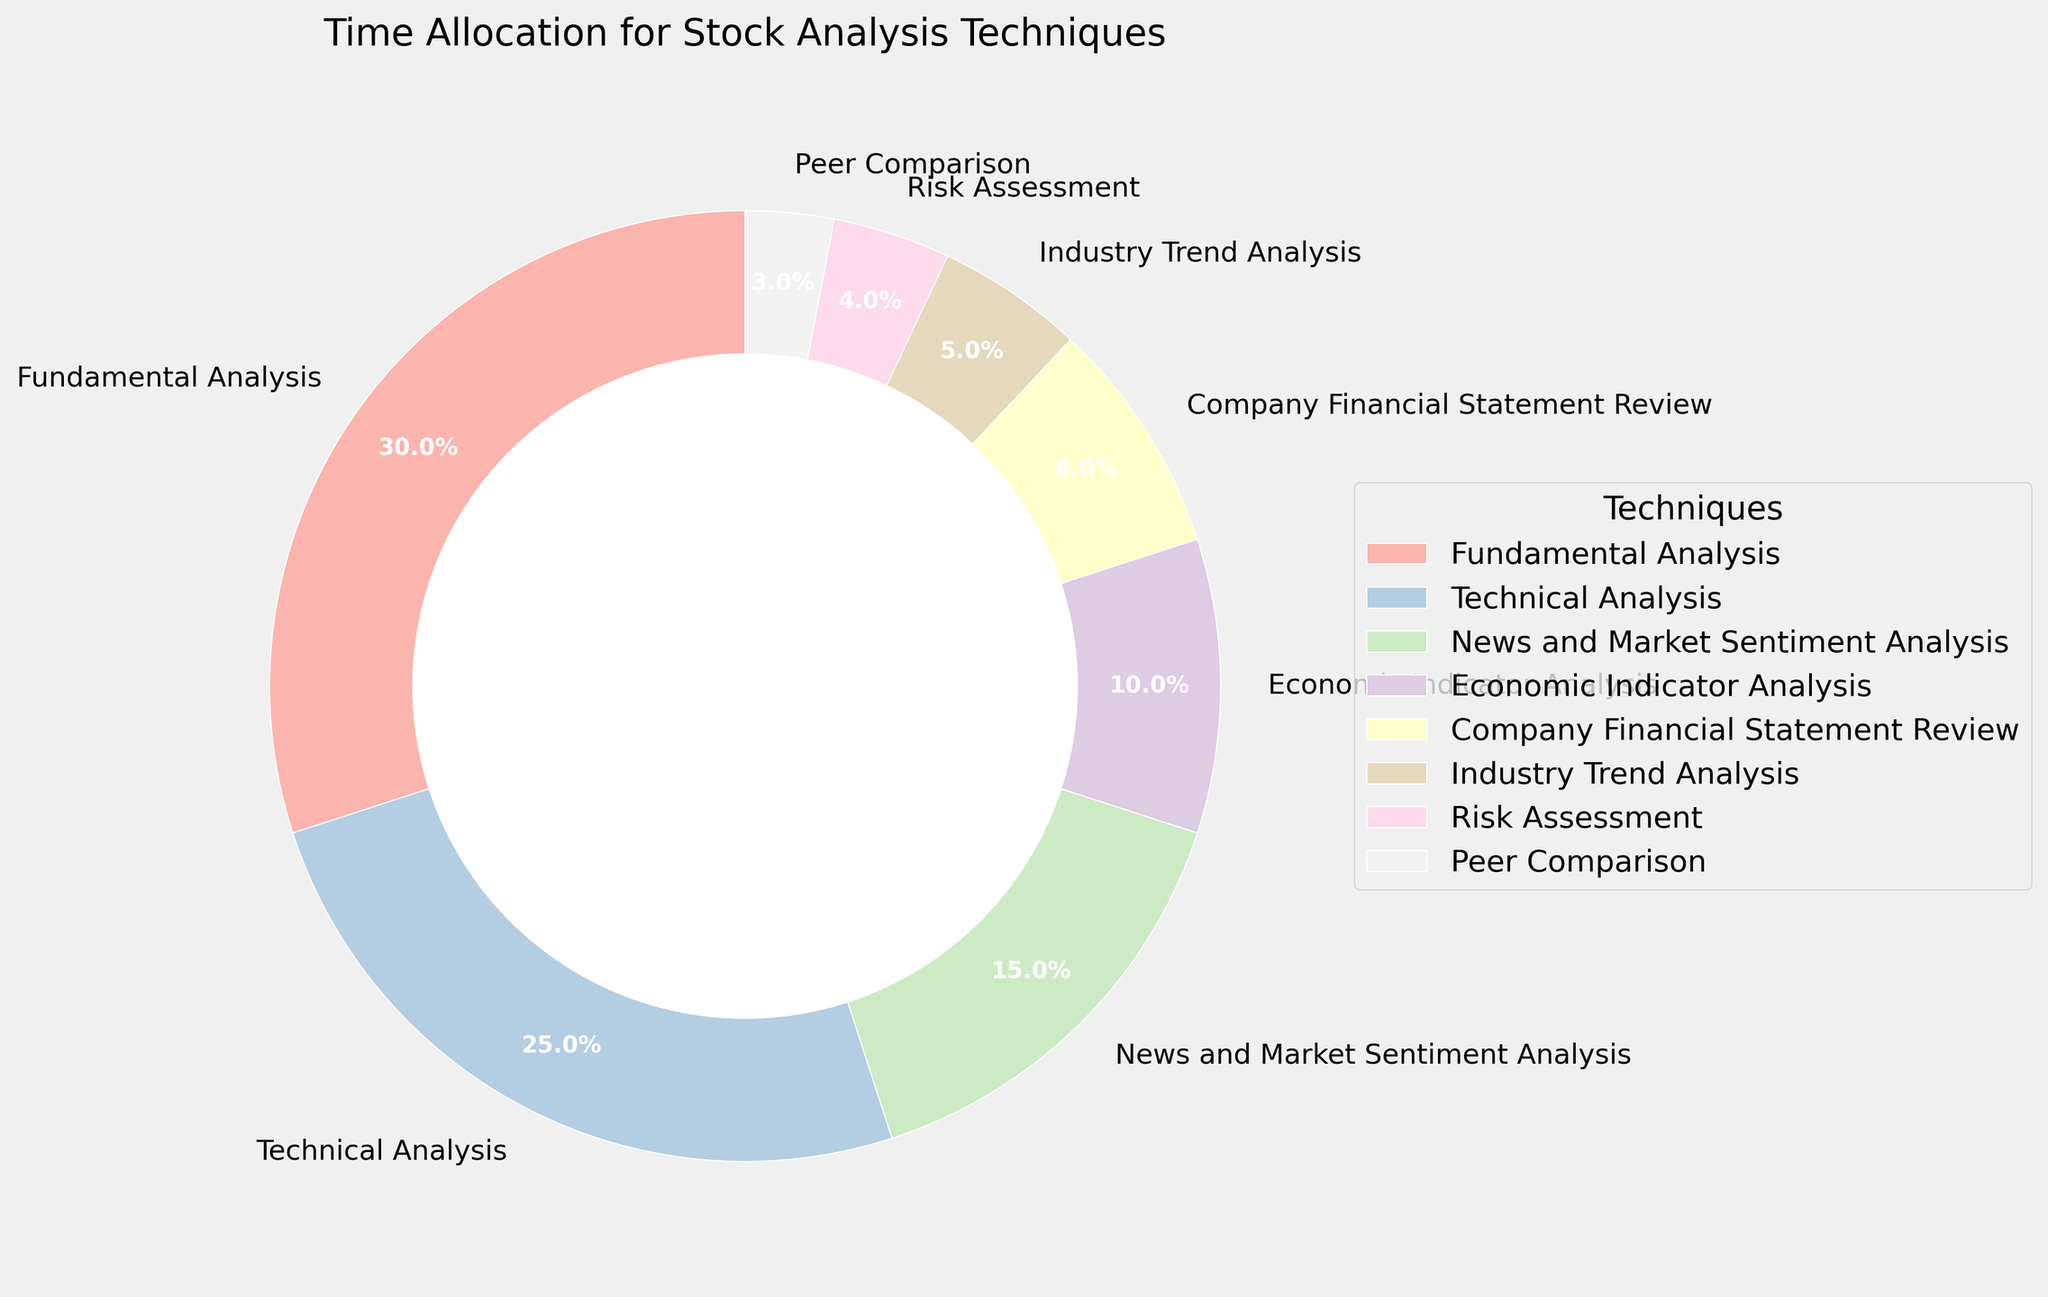What percentage of time is allocated to Fundamental Analysis? According to the pie chart, the slice representing Fundamental Analysis is labeled with a percentage. By reading that label, we find that Fundamental Analysis takes up 30% of the time.
Answer: 30% Which stock analysis technique has the smallest time allocation? The smallest slice of the pie chart is labeled with the technique and percentage. The slice representing Peer Comparison is the smallest with 3%.
Answer: Peer Comparison How much more time is allocated to Technical Analysis compared to Industry Trend Analysis? To find the difference, we subtract the percentage for Industry Trend Analysis from the percentage for Technical Analysis: 25% (Technical Analysis) - 5% (Industry Trend Analysis) = 20%.
Answer: 20% If we combine the time allocated to News and Market Sentiment Analysis and Economic Indicator Analysis, what percentage do we get? Adding the percentages for News and Market Sentiment Analysis (15%) and Economic Indicator Analysis (10%) gives 25%.
Answer: 25% Which techniques together constitute half of the total time allocation? The total time is 100%. Half of this is 50%. Adding the largest slices until the total reaches or exceeds 50%, we get Fundamental Analysis (30%) + Technical Analysis (25%) = 55%. Therefore, these two techniques together constitute more than half of the total time allocation.
Answer: Fundamental Analysis and Technical Analysis What is the visual difference in width between the slices for Technical Analysis and Company Financial Statement Review? From the pie chart, we see that the Technical Analysis slice is significantly wider than the Company Financial Statement Review slice, indicating a higher percentage allocation.
Answer: Technical Analysis is wider Which technique has approximately double the time allocation of Economic Indicator Analysis? The pie chart shows the percentage for Economic Indicator Analysis as 10%. The slice for Technical Analysis is approximately double this at 25%.
Answer: Technical Analysis Compare the combined time allocation for Economic Indicator Analysis and Company Financial Statement Review to the time allocated to Fundamental Analysis. Which is larger? Adding the percentages for Economic Indicator Analysis (10%) and Company Financial Statement Review (8%) gives 18%. This is less than the 30% allocated to Fundamental Analysis.
Answer: Fundamental Analysis is larger What is the percentage difference between the time allocated to Risk Assessment and Industry Trend Analysis? Subtracting the percentage for Risk Assessment (4%) from the percentage for Industry Trend Analysis (5%) gives 1%.
Answer: 1% Identify the total percentage allocated to all the techniques that have less than 10% time allocation each. Adding the percentages for Company Financial Statement Review (8%), Industry Trend Analysis (5%), Risk Assessment (4%), and Peer Comparison (3%) gives 20%.
Answer: 20% 